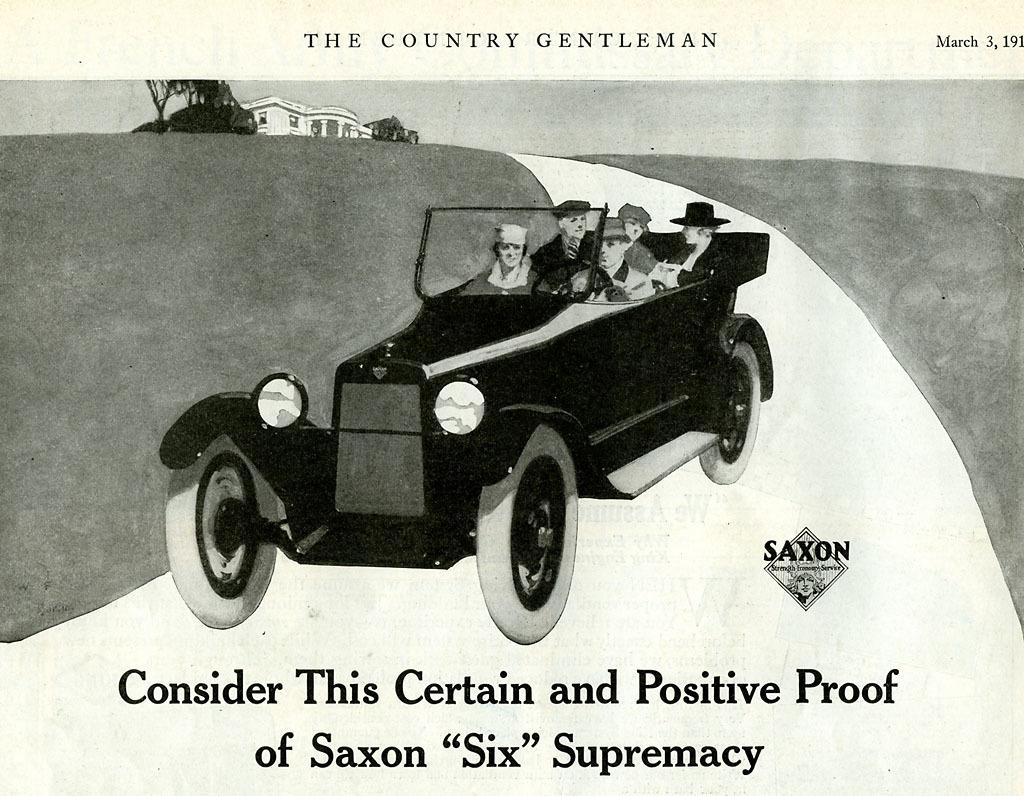What is the main subject of the poster in the image? The poster contains a picture of a vehicle. Are there any other elements in the poster besides the vehicle? Yes, the poster contains people, trees, a house, and text. What type of text is present on the poster? There is text written on the poster. How many boats can be seen sailing in the background of the poster? There are no boats visible in the poster; it features a vehicle, people, trees, and a house. What type of learning material is depicted in the poster? There is no learning material depicted in the poster; it contains a vehicle, people, trees, and a house. 